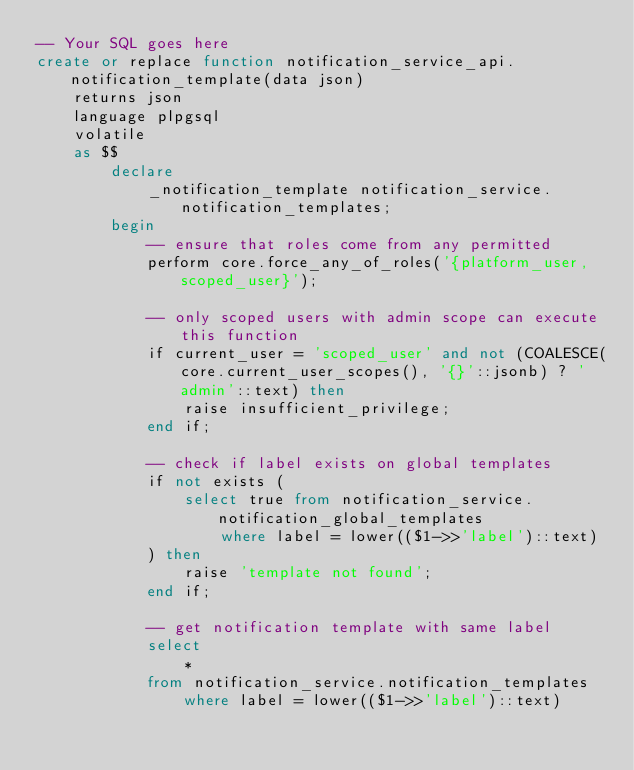<code> <loc_0><loc_0><loc_500><loc_500><_SQL_>-- Your SQL goes here
create or replace function notification_service_api.notification_template(data json)
    returns json
    language plpgsql
    volatile
    as $$
        declare
            _notification_template notification_service.notification_templates;
        begin
            -- ensure that roles come from any permitted
            perform core.force_any_of_roles('{platform_user,scoped_user}');
            
            -- only scoped users with admin scope can execute this function
            if current_user = 'scoped_user' and not (COALESCE(core.current_user_scopes(), '{}'::jsonb) ? 'admin'::text) then
                raise insufficient_privilege;
            end if;
            
            -- check if label exists on global templates
            if not exists (
                select true from notification_service.notification_global_templates
                    where label = lower(($1->>'label')::text)
            ) then
                raise 'template not found';
            end if;
            
            -- get notification template with same label
            select
                *
            from notification_service.notification_templates
                where label = lower(($1->>'label')::text)</code> 